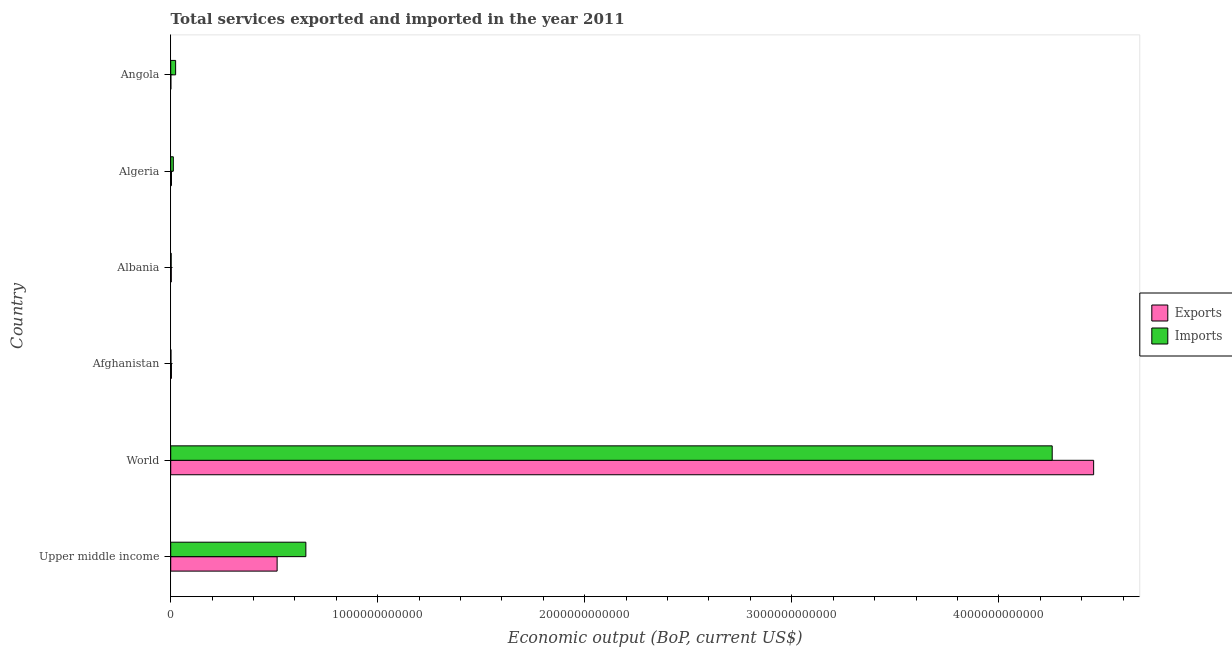How many different coloured bars are there?
Offer a terse response. 2. Are the number of bars on each tick of the Y-axis equal?
Keep it short and to the point. Yes. How many bars are there on the 4th tick from the bottom?
Your answer should be compact. 2. What is the label of the 3rd group of bars from the top?
Provide a succinct answer. Albania. What is the amount of service imports in Upper middle income?
Provide a succinct answer. 6.53e+11. Across all countries, what is the maximum amount of service imports?
Your response must be concise. 4.26e+12. Across all countries, what is the minimum amount of service exports?
Your response must be concise. 7.32e+08. In which country was the amount of service imports maximum?
Offer a very short reply. World. In which country was the amount of service exports minimum?
Provide a succinct answer. Angola. What is the total amount of service exports in the graph?
Ensure brevity in your answer.  4.98e+12. What is the difference between the amount of service imports in Afghanistan and that in World?
Offer a terse response. -4.26e+12. What is the difference between the amount of service imports in World and the amount of service exports in Upper middle income?
Offer a very short reply. 3.74e+12. What is the average amount of service exports per country?
Your answer should be very brief. 8.30e+11. What is the difference between the amount of service exports and amount of service imports in Afghanistan?
Provide a short and direct response. 2.19e+09. What is the ratio of the amount of service imports in Afghanistan to that in Angola?
Provide a succinct answer. 0.05. Is the difference between the amount of service exports in Afghanistan and Upper middle income greater than the difference between the amount of service imports in Afghanistan and Upper middle income?
Your answer should be very brief. Yes. What is the difference between the highest and the second highest amount of service imports?
Offer a terse response. 3.61e+12. What is the difference between the highest and the lowest amount of service exports?
Keep it short and to the point. 4.46e+12. Is the sum of the amount of service exports in Albania and Upper middle income greater than the maximum amount of service imports across all countries?
Your response must be concise. No. What does the 1st bar from the top in Algeria represents?
Your answer should be very brief. Imports. What does the 1st bar from the bottom in Albania represents?
Give a very brief answer. Exports. Are all the bars in the graph horizontal?
Offer a very short reply. Yes. How many countries are there in the graph?
Keep it short and to the point. 6. What is the difference between two consecutive major ticks on the X-axis?
Keep it short and to the point. 1.00e+12. Does the graph contain any zero values?
Ensure brevity in your answer.  No. Where does the legend appear in the graph?
Make the answer very short. Center right. What is the title of the graph?
Your answer should be very brief. Total services exported and imported in the year 2011. Does "Foreign Liabilities" appear as one of the legend labels in the graph?
Provide a succinct answer. No. What is the label or title of the X-axis?
Provide a succinct answer. Economic output (BoP, current US$). What is the label or title of the Y-axis?
Make the answer very short. Country. What is the Economic output (BoP, current US$) of Exports in Upper middle income?
Your answer should be compact. 5.14e+11. What is the Economic output (BoP, current US$) in Imports in Upper middle income?
Your response must be concise. 6.53e+11. What is the Economic output (BoP, current US$) of Exports in World?
Offer a terse response. 4.46e+12. What is the Economic output (BoP, current US$) of Imports in World?
Provide a succinct answer. 4.26e+12. What is the Economic output (BoP, current US$) in Exports in Afghanistan?
Offer a very short reply. 3.48e+09. What is the Economic output (BoP, current US$) in Imports in Afghanistan?
Offer a very short reply. 1.29e+09. What is the Economic output (BoP, current US$) in Exports in Albania?
Ensure brevity in your answer.  2.81e+09. What is the Economic output (BoP, current US$) in Imports in Albania?
Give a very brief answer. 2.25e+09. What is the Economic output (BoP, current US$) in Exports in Algeria?
Your response must be concise. 3.73e+09. What is the Economic output (BoP, current US$) in Imports in Algeria?
Provide a succinct answer. 1.26e+1. What is the Economic output (BoP, current US$) in Exports in Angola?
Provide a succinct answer. 7.32e+08. What is the Economic output (BoP, current US$) of Imports in Angola?
Your answer should be compact. 2.37e+1. Across all countries, what is the maximum Economic output (BoP, current US$) of Exports?
Offer a very short reply. 4.46e+12. Across all countries, what is the maximum Economic output (BoP, current US$) in Imports?
Offer a terse response. 4.26e+12. Across all countries, what is the minimum Economic output (BoP, current US$) in Exports?
Your answer should be compact. 7.32e+08. Across all countries, what is the minimum Economic output (BoP, current US$) of Imports?
Ensure brevity in your answer.  1.29e+09. What is the total Economic output (BoP, current US$) of Exports in the graph?
Offer a terse response. 4.98e+12. What is the total Economic output (BoP, current US$) of Imports in the graph?
Provide a succinct answer. 4.95e+12. What is the difference between the Economic output (BoP, current US$) in Exports in Upper middle income and that in World?
Provide a short and direct response. -3.94e+12. What is the difference between the Economic output (BoP, current US$) of Imports in Upper middle income and that in World?
Your response must be concise. -3.61e+12. What is the difference between the Economic output (BoP, current US$) in Exports in Upper middle income and that in Afghanistan?
Make the answer very short. 5.11e+11. What is the difference between the Economic output (BoP, current US$) in Imports in Upper middle income and that in Afghanistan?
Your response must be concise. 6.52e+11. What is the difference between the Economic output (BoP, current US$) in Exports in Upper middle income and that in Albania?
Your answer should be compact. 5.11e+11. What is the difference between the Economic output (BoP, current US$) of Imports in Upper middle income and that in Albania?
Give a very brief answer. 6.51e+11. What is the difference between the Economic output (BoP, current US$) of Exports in Upper middle income and that in Algeria?
Offer a very short reply. 5.10e+11. What is the difference between the Economic output (BoP, current US$) in Imports in Upper middle income and that in Algeria?
Your answer should be very brief. 6.40e+11. What is the difference between the Economic output (BoP, current US$) of Exports in Upper middle income and that in Angola?
Give a very brief answer. 5.13e+11. What is the difference between the Economic output (BoP, current US$) of Imports in Upper middle income and that in Angola?
Provide a short and direct response. 6.29e+11. What is the difference between the Economic output (BoP, current US$) of Exports in World and that in Afghanistan?
Your response must be concise. 4.45e+12. What is the difference between the Economic output (BoP, current US$) of Imports in World and that in Afghanistan?
Your answer should be very brief. 4.26e+12. What is the difference between the Economic output (BoP, current US$) in Exports in World and that in Albania?
Provide a short and direct response. 4.46e+12. What is the difference between the Economic output (BoP, current US$) in Imports in World and that in Albania?
Your response must be concise. 4.26e+12. What is the difference between the Economic output (BoP, current US$) of Exports in World and that in Algeria?
Provide a succinct answer. 4.45e+12. What is the difference between the Economic output (BoP, current US$) of Imports in World and that in Algeria?
Offer a terse response. 4.25e+12. What is the difference between the Economic output (BoP, current US$) in Exports in World and that in Angola?
Provide a succinct answer. 4.46e+12. What is the difference between the Economic output (BoP, current US$) of Imports in World and that in Angola?
Keep it short and to the point. 4.23e+12. What is the difference between the Economic output (BoP, current US$) of Exports in Afghanistan and that in Albania?
Your response must be concise. 6.62e+08. What is the difference between the Economic output (BoP, current US$) in Imports in Afghanistan and that in Albania?
Your answer should be very brief. -9.59e+08. What is the difference between the Economic output (BoP, current US$) in Exports in Afghanistan and that in Algeria?
Offer a very short reply. -2.51e+08. What is the difference between the Economic output (BoP, current US$) of Imports in Afghanistan and that in Algeria?
Provide a succinct answer. -1.13e+1. What is the difference between the Economic output (BoP, current US$) in Exports in Afghanistan and that in Angola?
Your answer should be very brief. 2.74e+09. What is the difference between the Economic output (BoP, current US$) in Imports in Afghanistan and that in Angola?
Offer a very short reply. -2.24e+1. What is the difference between the Economic output (BoP, current US$) of Exports in Albania and that in Algeria?
Give a very brief answer. -9.13e+08. What is the difference between the Economic output (BoP, current US$) in Imports in Albania and that in Algeria?
Make the answer very short. -1.04e+1. What is the difference between the Economic output (BoP, current US$) of Exports in Albania and that in Angola?
Your answer should be very brief. 2.08e+09. What is the difference between the Economic output (BoP, current US$) in Imports in Albania and that in Angola?
Ensure brevity in your answer.  -2.14e+1. What is the difference between the Economic output (BoP, current US$) of Exports in Algeria and that in Angola?
Your response must be concise. 3.00e+09. What is the difference between the Economic output (BoP, current US$) of Imports in Algeria and that in Angola?
Your answer should be very brief. -1.11e+1. What is the difference between the Economic output (BoP, current US$) of Exports in Upper middle income and the Economic output (BoP, current US$) of Imports in World?
Offer a very short reply. -3.74e+12. What is the difference between the Economic output (BoP, current US$) in Exports in Upper middle income and the Economic output (BoP, current US$) in Imports in Afghanistan?
Offer a terse response. 5.13e+11. What is the difference between the Economic output (BoP, current US$) in Exports in Upper middle income and the Economic output (BoP, current US$) in Imports in Albania?
Ensure brevity in your answer.  5.12e+11. What is the difference between the Economic output (BoP, current US$) of Exports in Upper middle income and the Economic output (BoP, current US$) of Imports in Algeria?
Ensure brevity in your answer.  5.01e+11. What is the difference between the Economic output (BoP, current US$) of Exports in Upper middle income and the Economic output (BoP, current US$) of Imports in Angola?
Provide a short and direct response. 4.90e+11. What is the difference between the Economic output (BoP, current US$) in Exports in World and the Economic output (BoP, current US$) in Imports in Afghanistan?
Your answer should be compact. 4.46e+12. What is the difference between the Economic output (BoP, current US$) in Exports in World and the Economic output (BoP, current US$) in Imports in Albania?
Make the answer very short. 4.46e+12. What is the difference between the Economic output (BoP, current US$) of Exports in World and the Economic output (BoP, current US$) of Imports in Algeria?
Provide a succinct answer. 4.45e+12. What is the difference between the Economic output (BoP, current US$) in Exports in World and the Economic output (BoP, current US$) in Imports in Angola?
Your answer should be very brief. 4.43e+12. What is the difference between the Economic output (BoP, current US$) in Exports in Afghanistan and the Economic output (BoP, current US$) in Imports in Albania?
Keep it short and to the point. 1.23e+09. What is the difference between the Economic output (BoP, current US$) of Exports in Afghanistan and the Economic output (BoP, current US$) of Imports in Algeria?
Offer a very short reply. -9.12e+09. What is the difference between the Economic output (BoP, current US$) in Exports in Afghanistan and the Economic output (BoP, current US$) in Imports in Angola?
Your answer should be compact. -2.02e+1. What is the difference between the Economic output (BoP, current US$) in Exports in Albania and the Economic output (BoP, current US$) in Imports in Algeria?
Offer a very short reply. -9.78e+09. What is the difference between the Economic output (BoP, current US$) of Exports in Albania and the Economic output (BoP, current US$) of Imports in Angola?
Ensure brevity in your answer.  -2.09e+1. What is the difference between the Economic output (BoP, current US$) of Exports in Algeria and the Economic output (BoP, current US$) of Imports in Angola?
Your answer should be compact. -1.99e+1. What is the average Economic output (BoP, current US$) in Exports per country?
Your answer should be compact. 8.30e+11. What is the average Economic output (BoP, current US$) of Imports per country?
Your response must be concise. 8.25e+11. What is the difference between the Economic output (BoP, current US$) of Exports and Economic output (BoP, current US$) of Imports in Upper middle income?
Your answer should be compact. -1.39e+11. What is the difference between the Economic output (BoP, current US$) of Exports and Economic output (BoP, current US$) of Imports in World?
Ensure brevity in your answer.  2.00e+11. What is the difference between the Economic output (BoP, current US$) of Exports and Economic output (BoP, current US$) of Imports in Afghanistan?
Provide a succinct answer. 2.19e+09. What is the difference between the Economic output (BoP, current US$) of Exports and Economic output (BoP, current US$) of Imports in Albania?
Your answer should be very brief. 5.66e+08. What is the difference between the Economic output (BoP, current US$) in Exports and Economic output (BoP, current US$) in Imports in Algeria?
Your answer should be very brief. -8.87e+09. What is the difference between the Economic output (BoP, current US$) in Exports and Economic output (BoP, current US$) in Imports in Angola?
Offer a very short reply. -2.29e+1. What is the ratio of the Economic output (BoP, current US$) of Exports in Upper middle income to that in World?
Provide a short and direct response. 0.12. What is the ratio of the Economic output (BoP, current US$) of Imports in Upper middle income to that in World?
Give a very brief answer. 0.15. What is the ratio of the Economic output (BoP, current US$) in Exports in Upper middle income to that in Afghanistan?
Make the answer very short. 147.87. What is the ratio of the Economic output (BoP, current US$) of Imports in Upper middle income to that in Afghanistan?
Give a very brief answer. 506.21. What is the ratio of the Economic output (BoP, current US$) of Exports in Upper middle income to that in Albania?
Your answer should be compact. 182.63. What is the ratio of the Economic output (BoP, current US$) of Imports in Upper middle income to that in Albania?
Offer a terse response. 290.36. What is the ratio of the Economic output (BoP, current US$) in Exports in Upper middle income to that in Algeria?
Offer a terse response. 137.9. What is the ratio of the Economic output (BoP, current US$) in Imports in Upper middle income to that in Algeria?
Offer a terse response. 51.81. What is the ratio of the Economic output (BoP, current US$) in Exports in Upper middle income to that in Angola?
Your answer should be very brief. 701.94. What is the ratio of the Economic output (BoP, current US$) of Imports in Upper middle income to that in Angola?
Offer a very short reply. 27.58. What is the ratio of the Economic output (BoP, current US$) in Exports in World to that in Afghanistan?
Your answer should be very brief. 1282.55. What is the ratio of the Economic output (BoP, current US$) in Imports in World to that in Afghanistan?
Offer a terse response. 3301.72. What is the ratio of the Economic output (BoP, current US$) of Exports in World to that in Albania?
Give a very brief answer. 1584.02. What is the ratio of the Economic output (BoP, current US$) in Imports in World to that in Albania?
Your answer should be very brief. 1893.8. What is the ratio of the Economic output (BoP, current US$) in Exports in World to that in Algeria?
Your answer should be very brief. 1196.02. What is the ratio of the Economic output (BoP, current US$) of Imports in World to that in Algeria?
Make the answer very short. 337.95. What is the ratio of the Economic output (BoP, current US$) in Exports in World to that in Angola?
Your response must be concise. 6088.18. What is the ratio of the Economic output (BoP, current US$) in Imports in World to that in Angola?
Your answer should be compact. 179.89. What is the ratio of the Economic output (BoP, current US$) of Exports in Afghanistan to that in Albania?
Offer a terse response. 1.24. What is the ratio of the Economic output (BoP, current US$) of Imports in Afghanistan to that in Albania?
Keep it short and to the point. 0.57. What is the ratio of the Economic output (BoP, current US$) in Exports in Afghanistan to that in Algeria?
Provide a succinct answer. 0.93. What is the ratio of the Economic output (BoP, current US$) in Imports in Afghanistan to that in Algeria?
Offer a terse response. 0.1. What is the ratio of the Economic output (BoP, current US$) in Exports in Afghanistan to that in Angola?
Make the answer very short. 4.75. What is the ratio of the Economic output (BoP, current US$) of Imports in Afghanistan to that in Angola?
Keep it short and to the point. 0.05. What is the ratio of the Economic output (BoP, current US$) of Exports in Albania to that in Algeria?
Provide a succinct answer. 0.76. What is the ratio of the Economic output (BoP, current US$) of Imports in Albania to that in Algeria?
Your response must be concise. 0.18. What is the ratio of the Economic output (BoP, current US$) in Exports in Albania to that in Angola?
Offer a terse response. 3.84. What is the ratio of the Economic output (BoP, current US$) of Imports in Albania to that in Angola?
Give a very brief answer. 0.1. What is the ratio of the Economic output (BoP, current US$) of Exports in Algeria to that in Angola?
Offer a very short reply. 5.09. What is the ratio of the Economic output (BoP, current US$) in Imports in Algeria to that in Angola?
Offer a very short reply. 0.53. What is the difference between the highest and the second highest Economic output (BoP, current US$) of Exports?
Provide a succinct answer. 3.94e+12. What is the difference between the highest and the second highest Economic output (BoP, current US$) of Imports?
Give a very brief answer. 3.61e+12. What is the difference between the highest and the lowest Economic output (BoP, current US$) of Exports?
Offer a very short reply. 4.46e+12. What is the difference between the highest and the lowest Economic output (BoP, current US$) of Imports?
Give a very brief answer. 4.26e+12. 